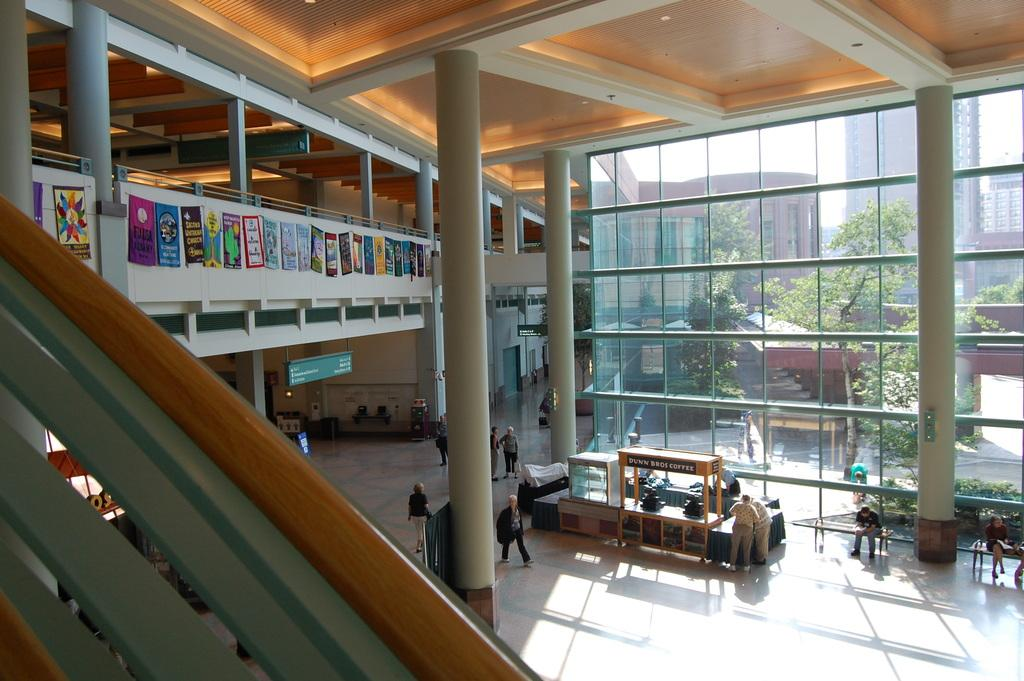What are the people in the image doing? The people in the image are on the floor. What can be seen near the people in the image? There is railing visible in the image. What architectural features are present in the image? There are pillars in the image. What decorative elements are present in the image? Banners are present in the image. What objects are visible in the image? Boards are visible in the image. What type of windows are present in the image? Glass windows are present in the image. What can be seen through the glass windows? Trees and buildings are visible through the glass windows. How many times did the people attempt to roll the pillars in the image? There is no indication in the image that the people are attempting to roll any pillars. Is there a dock visible in the image? There is no dock present in the image. 